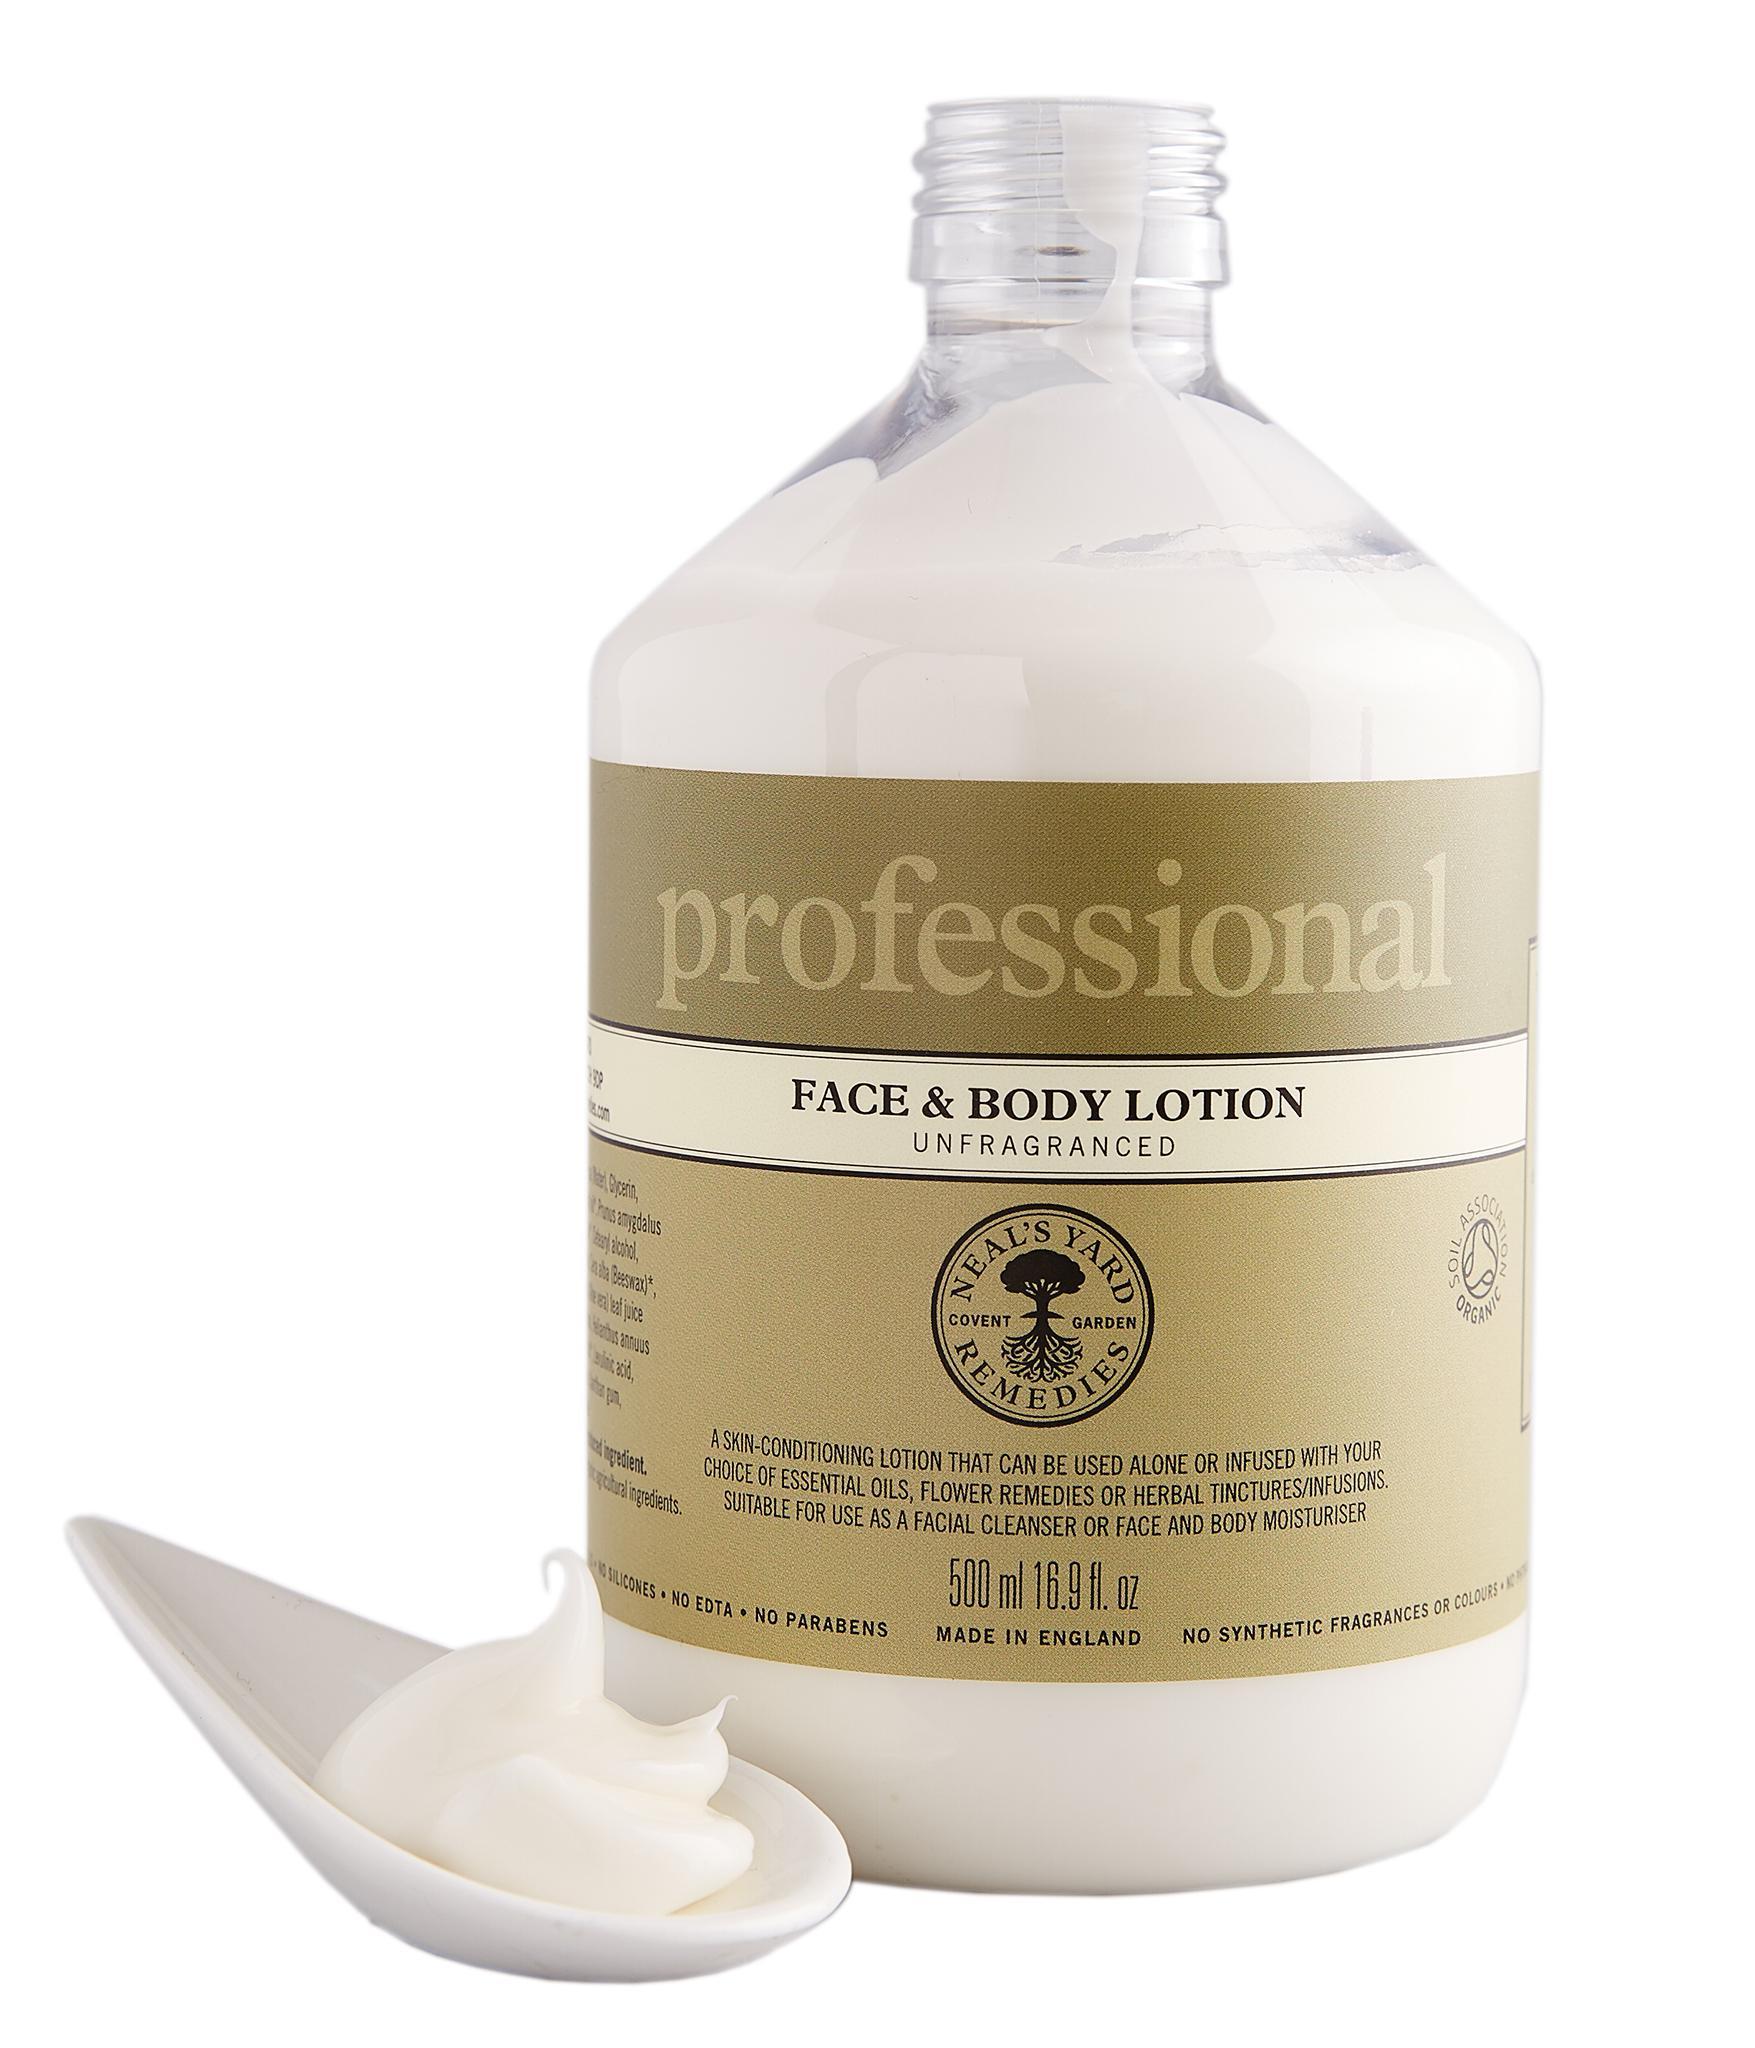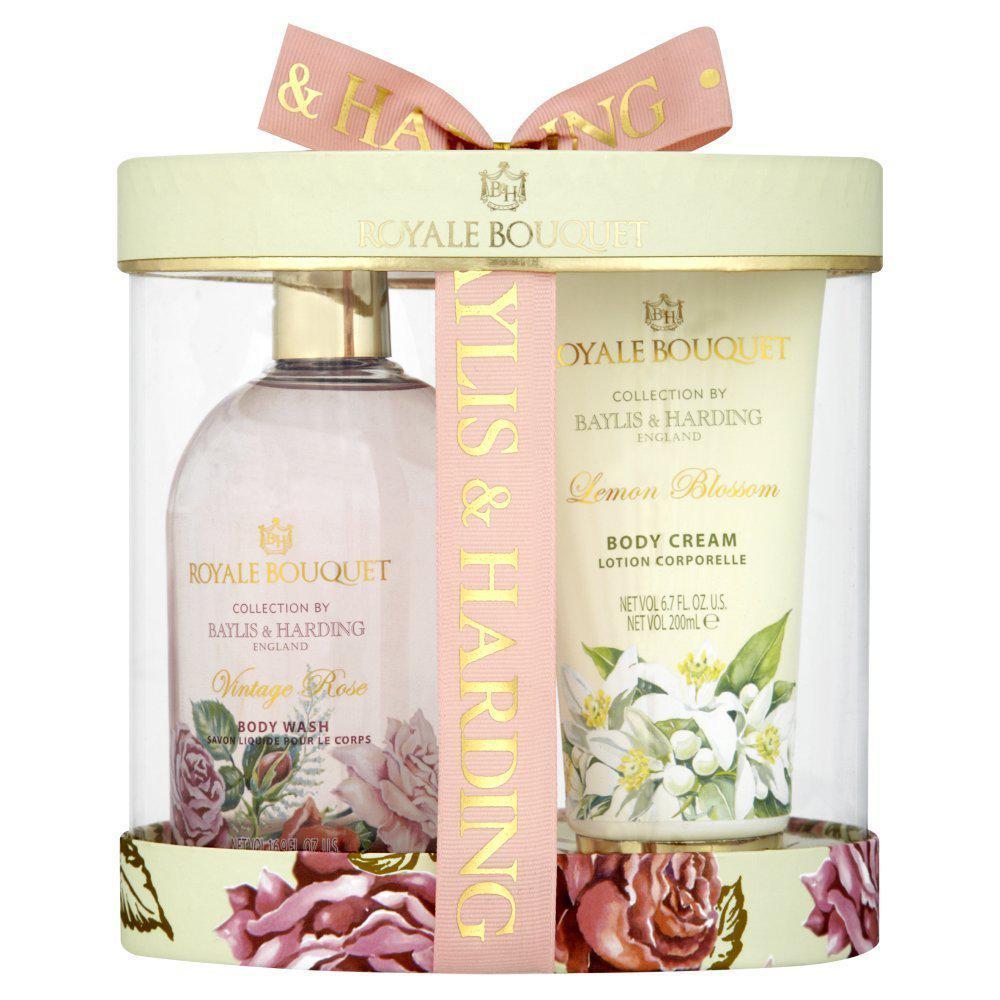The first image is the image on the left, the second image is the image on the right. Analyze the images presented: Is the assertion "Two containers of body wash have their cap on the bottom." valid? Answer yes or no. No. The first image is the image on the left, the second image is the image on the right. Considering the images on both sides, is "The right image shows a single product, which is decorated with lavender flowers, and left and right images show products in the same shape and applicator formats." valid? Answer yes or no. No. 